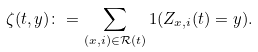<formula> <loc_0><loc_0><loc_500><loc_500>\zeta ( t , y ) \colon = \sum _ { ( x , i ) \in { \mathcal { R } } ( t ) } 1 ( Z _ { x , i } ( t ) = y ) .</formula> 